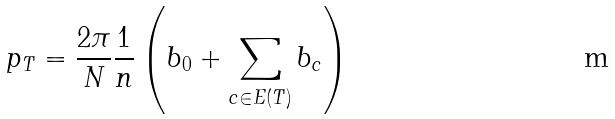<formula> <loc_0><loc_0><loc_500><loc_500>p _ { T } = \frac { 2 \pi } { N } \frac { 1 } { n } \left ( b _ { 0 } + \sum _ { c \in E ( T ) } b _ { c } \right )</formula> 